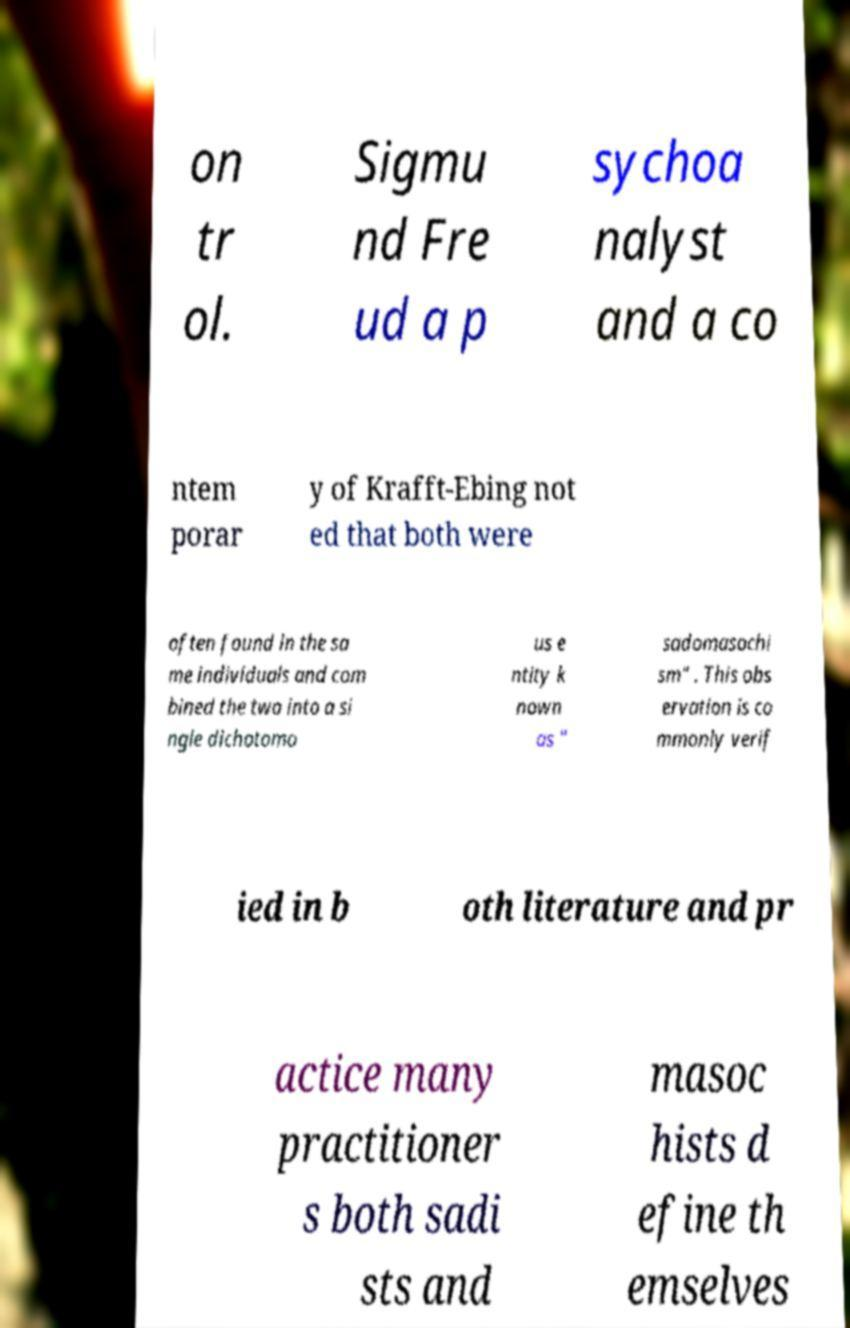Please read and relay the text visible in this image. What does it say? on tr ol. Sigmu nd Fre ud a p sychoa nalyst and a co ntem porar y of Krafft-Ebing not ed that both were often found in the sa me individuals and com bined the two into a si ngle dichotomo us e ntity k nown as " sadomasochi sm" . This obs ervation is co mmonly verif ied in b oth literature and pr actice many practitioner s both sadi sts and masoc hists d efine th emselves 